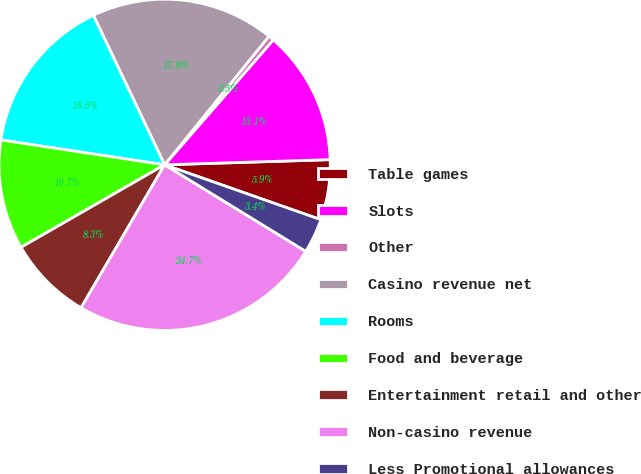<chart> <loc_0><loc_0><loc_500><loc_500><pie_chart><fcel>Table games<fcel>Slots<fcel>Other<fcel>Casino revenue net<fcel>Rooms<fcel>Food and beverage<fcel>Entertainment retail and other<fcel>Non-casino revenue<fcel>Less Promotional allowances<nl><fcel>5.87%<fcel>13.11%<fcel>0.54%<fcel>17.93%<fcel>15.52%<fcel>10.7%<fcel>8.28%<fcel>24.66%<fcel>3.38%<nl></chart> 